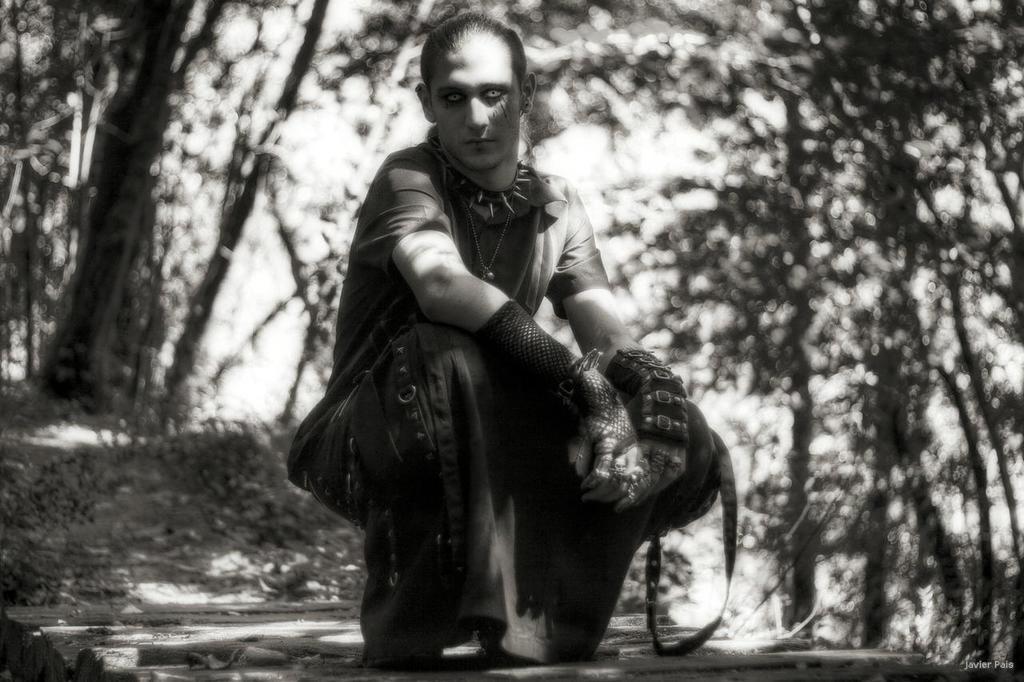In one or two sentences, can you explain what this image depicts? This is a black and white picture, there is a person sitting on the land, beside him there are trees all over the place. 